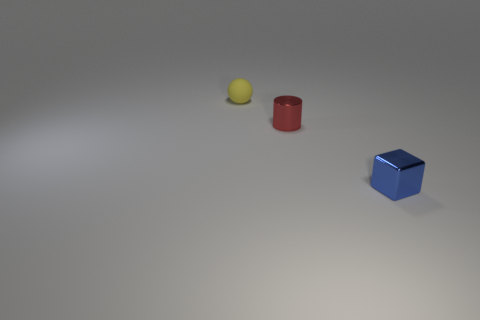Add 2 small red metal cylinders. How many objects exist? 5 Subtract all cubes. How many objects are left? 2 Subtract all tiny cylinders. Subtract all small metallic cylinders. How many objects are left? 1 Add 2 tiny yellow rubber objects. How many tiny yellow rubber objects are left? 3 Add 3 cylinders. How many cylinders exist? 4 Subtract 0 yellow cubes. How many objects are left? 3 